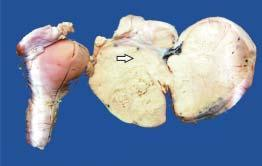does islands of mature cartilage show enlarged ovarian mass on one side which on cut section is solid, grey-white and firm?
Answer the question using a single word or phrase. No 